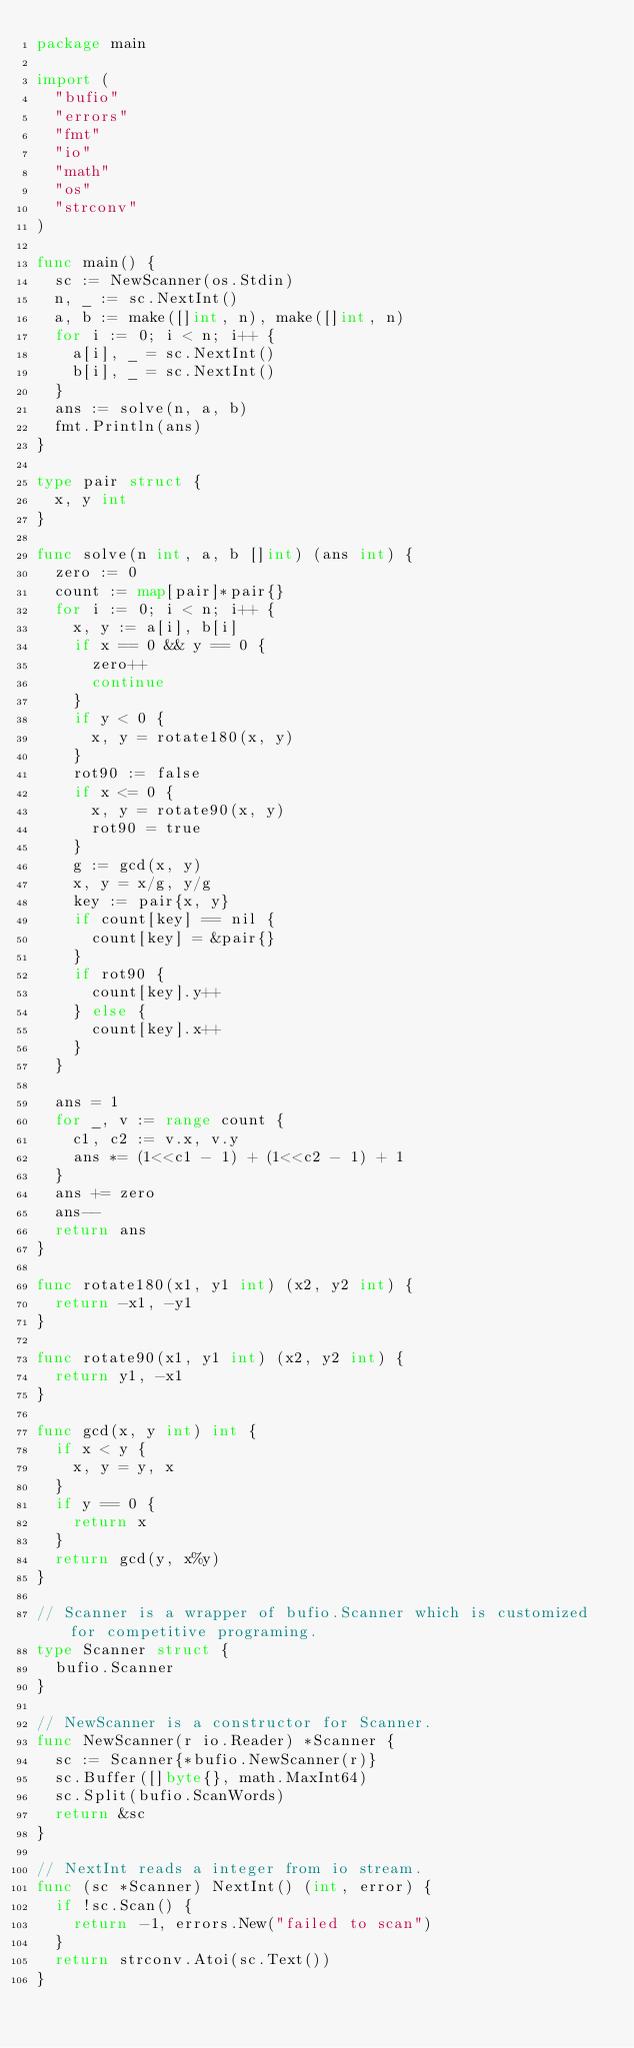<code> <loc_0><loc_0><loc_500><loc_500><_Go_>package main

import (
	"bufio"
	"errors"
	"fmt"
	"io"
	"math"
	"os"
	"strconv"
)

func main() {
	sc := NewScanner(os.Stdin)
	n, _ := sc.NextInt()
	a, b := make([]int, n), make([]int, n)
	for i := 0; i < n; i++ {
		a[i], _ = sc.NextInt()
		b[i], _ = sc.NextInt()
	}
	ans := solve(n, a, b)
	fmt.Println(ans)
}

type pair struct {
	x, y int
}

func solve(n int, a, b []int) (ans int) {
	zero := 0
	count := map[pair]*pair{}
	for i := 0; i < n; i++ {
		x, y := a[i], b[i]
		if x == 0 && y == 0 {
			zero++
			continue
		}
		if y < 0 {
			x, y = rotate180(x, y)
		}
		rot90 := false
		if x <= 0 {
			x, y = rotate90(x, y)
			rot90 = true
		}
		g := gcd(x, y)
		x, y = x/g, y/g
		key := pair{x, y}
		if count[key] == nil {
			count[key] = &pair{}
		}
		if rot90 {
			count[key].y++
		} else {
			count[key].x++
		}
	}

	ans = 1
	for _, v := range count {
		c1, c2 := v.x, v.y
		ans *= (1<<c1 - 1) + (1<<c2 - 1) + 1
	}
	ans += zero
	ans--
	return ans
}

func rotate180(x1, y1 int) (x2, y2 int) {
	return -x1, -y1
}

func rotate90(x1, y1 int) (x2, y2 int) {
	return y1, -x1
}

func gcd(x, y int) int {
	if x < y {
		x, y = y, x
	}
	if y == 0 {
		return x
	}
	return gcd(y, x%y)
}

// Scanner is a wrapper of bufio.Scanner which is customized for competitive programing.
type Scanner struct {
	bufio.Scanner
}

// NewScanner is a constructor for Scanner.
func NewScanner(r io.Reader) *Scanner {
	sc := Scanner{*bufio.NewScanner(r)}
	sc.Buffer([]byte{}, math.MaxInt64)
	sc.Split(bufio.ScanWords)
	return &sc
}

// NextInt reads a integer from io stream.
func (sc *Scanner) NextInt() (int, error) {
	if !sc.Scan() {
		return -1, errors.New("failed to scan")
	}
	return strconv.Atoi(sc.Text())
}
</code> 